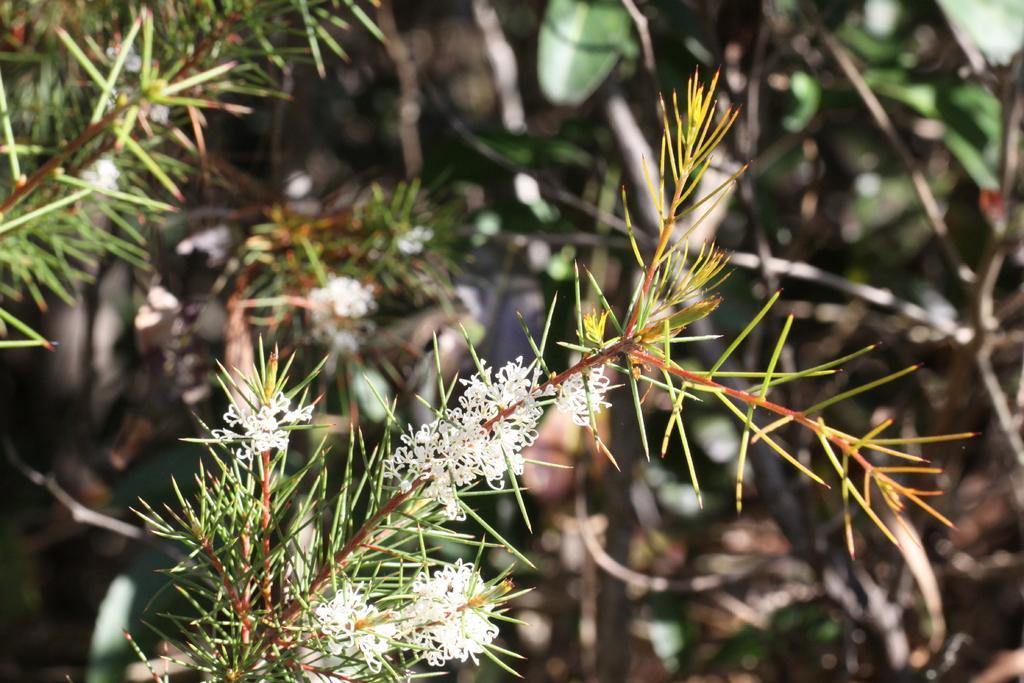Please provide a concise description of this image. In this image I can see some white color flowers to the plants. In the background I can see few more plants but it is blurry. 